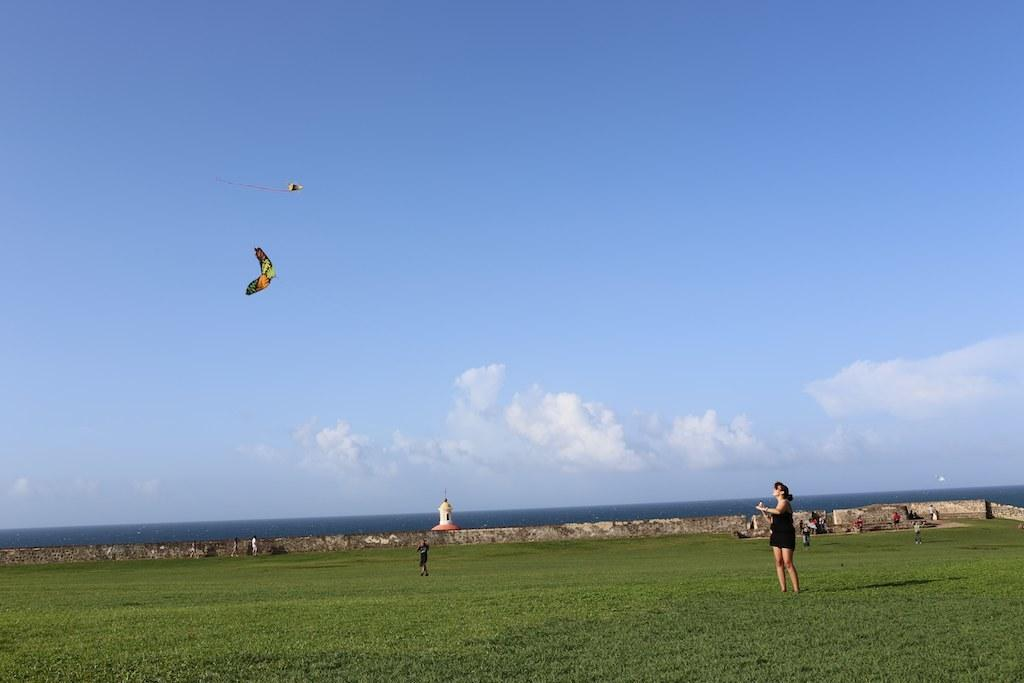How many people can be seen in the image? There are people in the image, but the exact number is not specified. What type of terrain is visible in the image? There is grass visible in the image. What are the people doing in the image? The presence of kites in the air suggests that the people might be flying kites. What is the background of the image? There is a wall, a lighthouse, water, and the sky visible in the background of the image. What is the weather like in the image? The presence of clouds in the sky suggests that the weather might be partly cloudy. What grade is the teacher giving to the students in the image? There is no indication of a teacher or students in the image, nor is there any mention of a grade being given. What type of stew is being served in the image? There is no food or stew present in the image. 